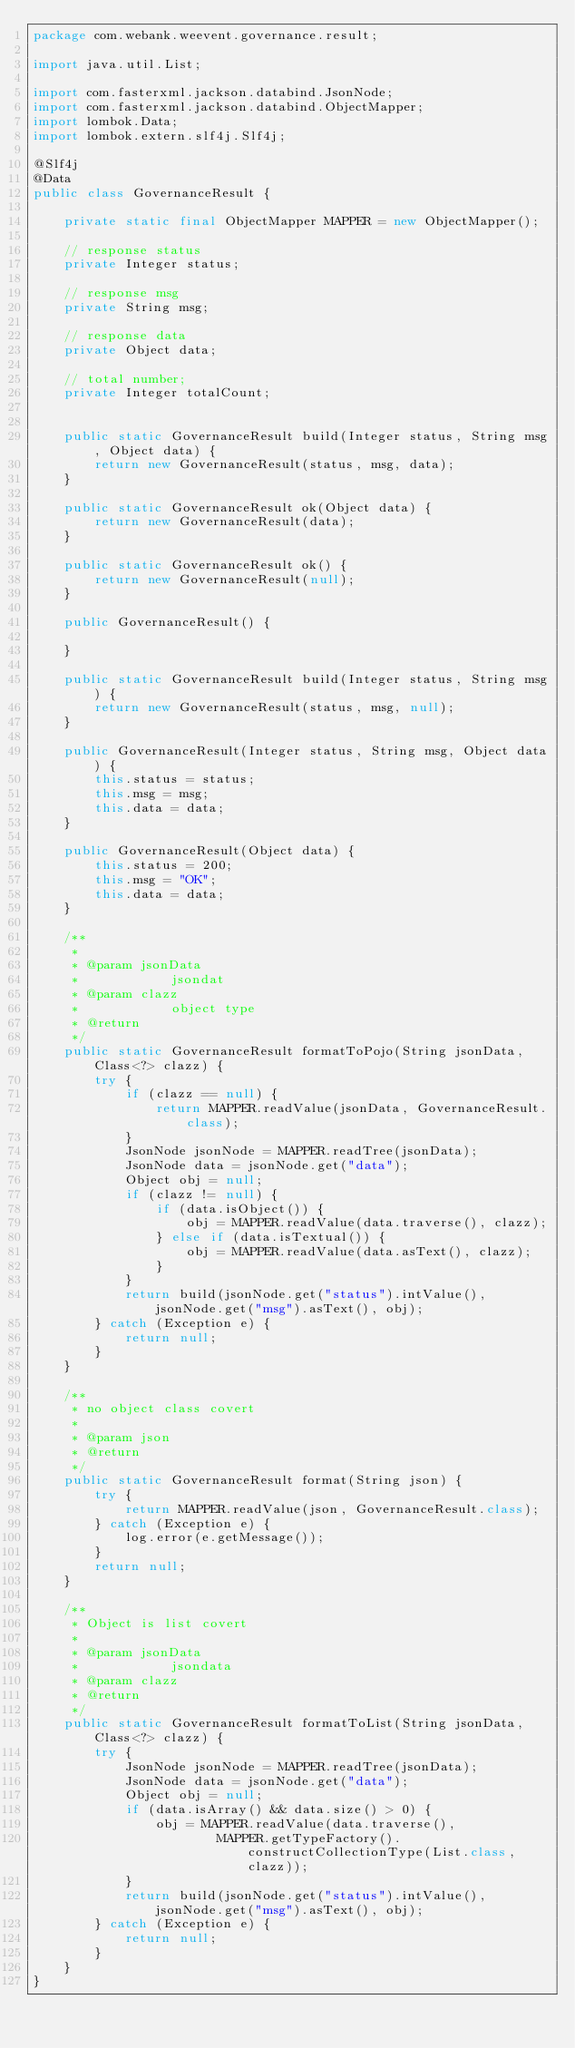Convert code to text. <code><loc_0><loc_0><loc_500><loc_500><_Java_>package com.webank.weevent.governance.result;

import java.util.List;

import com.fasterxml.jackson.databind.JsonNode;
import com.fasterxml.jackson.databind.ObjectMapper;
import lombok.Data;
import lombok.extern.slf4j.Slf4j;

@Slf4j
@Data
public class GovernanceResult {

    private static final ObjectMapper MAPPER = new ObjectMapper();

    // response status
    private Integer status;

    // response msg
    private String msg;

    // response data
    private Object data;

    // total number;
    private Integer totalCount;


    public static GovernanceResult build(Integer status, String msg, Object data) {
        return new GovernanceResult(status, msg, data);
    }

    public static GovernanceResult ok(Object data) {
        return new GovernanceResult(data);
    }

    public static GovernanceResult ok() {
        return new GovernanceResult(null);
    }

    public GovernanceResult() {

    }

    public static GovernanceResult build(Integer status, String msg) {
        return new GovernanceResult(status, msg, null);
    }

    public GovernanceResult(Integer status, String msg, Object data) {
        this.status = status;
        this.msg = msg;
        this.data = data;
    }

    public GovernanceResult(Object data) {
        this.status = 200;
        this.msg = "OK";
        this.data = data;
    }

    /**
     * 
     * @param jsonData
     *            jsondat
     * @param clazz
     *            object type
     * @return
     */
    public static GovernanceResult formatToPojo(String jsonData, Class<?> clazz) {
        try {
            if (clazz == null) {
                return MAPPER.readValue(jsonData, GovernanceResult.class);
            }
            JsonNode jsonNode = MAPPER.readTree(jsonData);
            JsonNode data = jsonNode.get("data");
            Object obj = null;
            if (clazz != null) {
                if (data.isObject()) {
                    obj = MAPPER.readValue(data.traverse(), clazz);
                } else if (data.isTextual()) {
                    obj = MAPPER.readValue(data.asText(), clazz);
                }
            }
            return build(jsonNode.get("status").intValue(), jsonNode.get("msg").asText(), obj);
        } catch (Exception e) {
            return null;
        }
    }

    /**
     * no object class covert
     * 
     * @param json
     * @return
     */
    public static GovernanceResult format(String json) {
        try {
            return MAPPER.readValue(json, GovernanceResult.class);
        } catch (Exception e) {
            log.error(e.getMessage());
        }
        return null;
    }

    /**
     * Object is list covert
     * 
     * @param jsonData
     *            jsondata
     * @param clazz
     * @return
     */
    public static GovernanceResult formatToList(String jsonData, Class<?> clazz) {
        try {
            JsonNode jsonNode = MAPPER.readTree(jsonData);
            JsonNode data = jsonNode.get("data");
            Object obj = null;
            if (data.isArray() && data.size() > 0) {
                obj = MAPPER.readValue(data.traverse(),
                        MAPPER.getTypeFactory().constructCollectionType(List.class, clazz));
            }
            return build(jsonNode.get("status").intValue(), jsonNode.get("msg").asText(), obj);
        } catch (Exception e) {
            return null;
        }
    }
}
</code> 